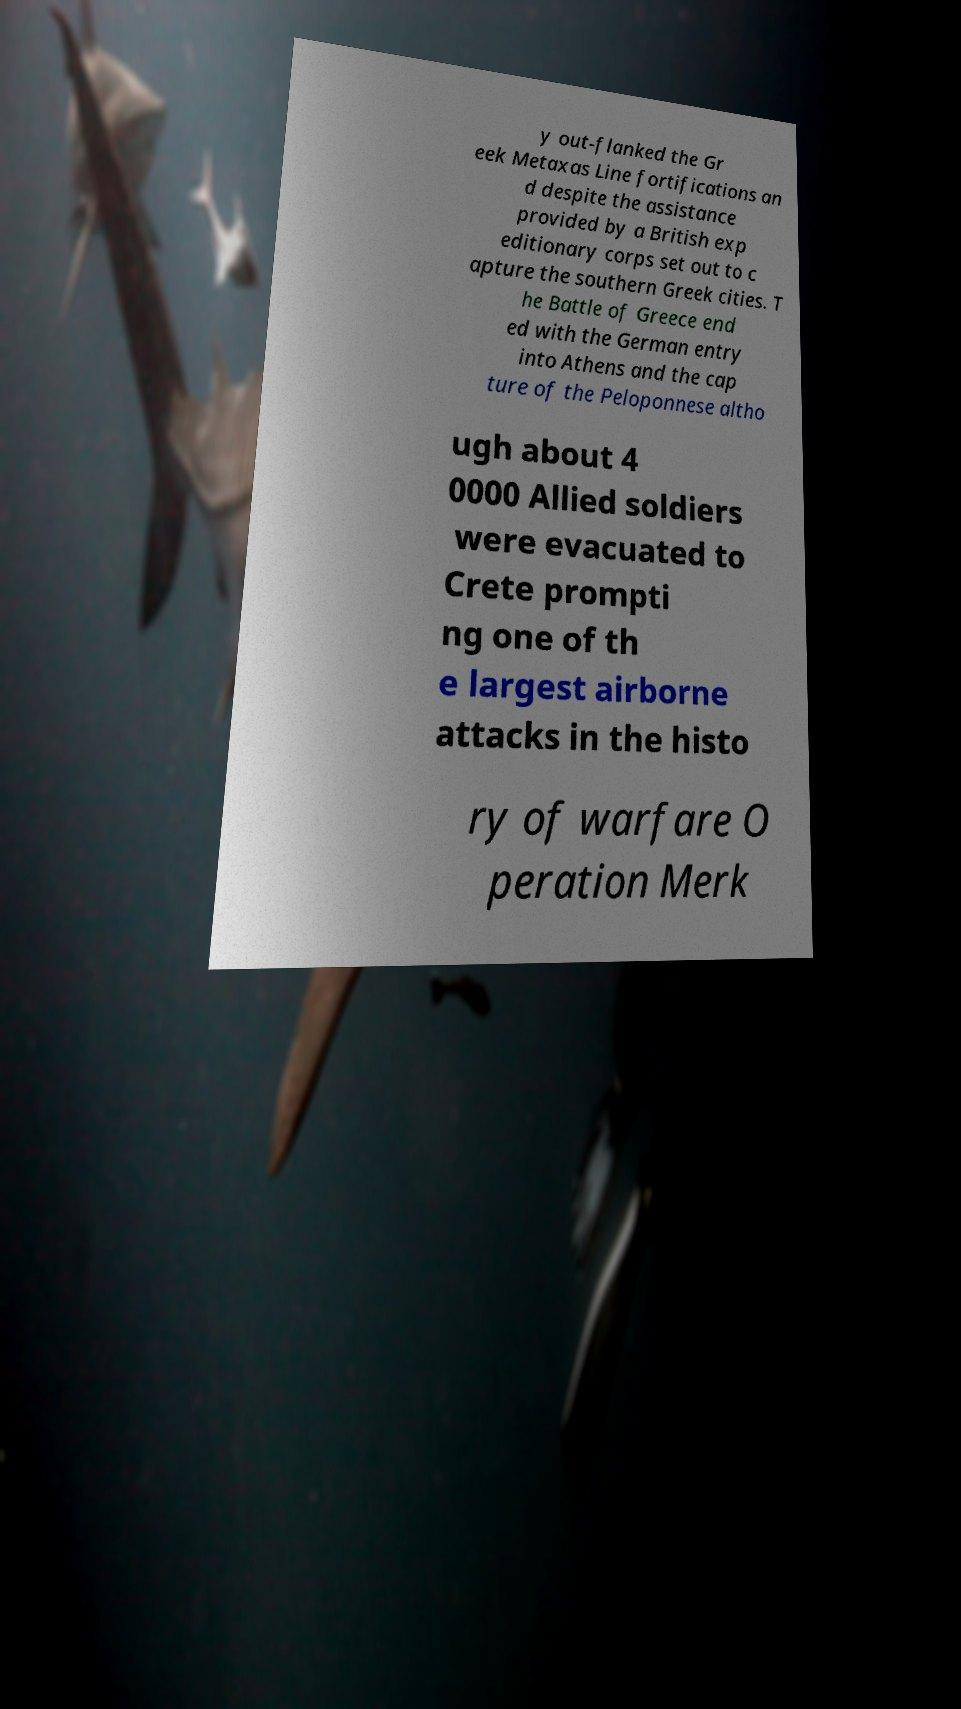I need the written content from this picture converted into text. Can you do that? y out-flanked the Gr eek Metaxas Line fortifications an d despite the assistance provided by a British exp editionary corps set out to c apture the southern Greek cities. T he Battle of Greece end ed with the German entry into Athens and the cap ture of the Peloponnese altho ugh about 4 0000 Allied soldiers were evacuated to Crete prompti ng one of th e largest airborne attacks in the histo ry of warfare O peration Merk 